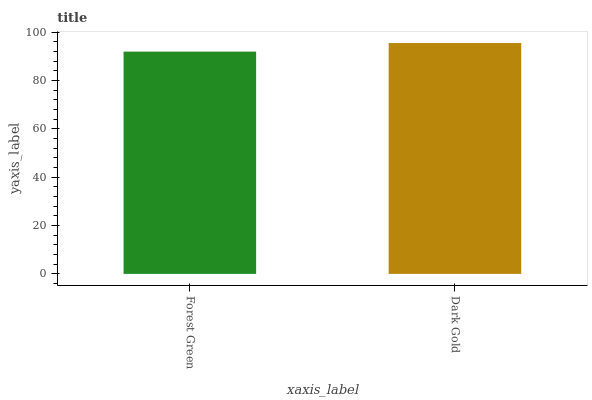Is Dark Gold the minimum?
Answer yes or no. No. Is Dark Gold greater than Forest Green?
Answer yes or no. Yes. Is Forest Green less than Dark Gold?
Answer yes or no. Yes. Is Forest Green greater than Dark Gold?
Answer yes or no. No. Is Dark Gold less than Forest Green?
Answer yes or no. No. Is Dark Gold the high median?
Answer yes or no. Yes. Is Forest Green the low median?
Answer yes or no. Yes. Is Forest Green the high median?
Answer yes or no. No. Is Dark Gold the low median?
Answer yes or no. No. 